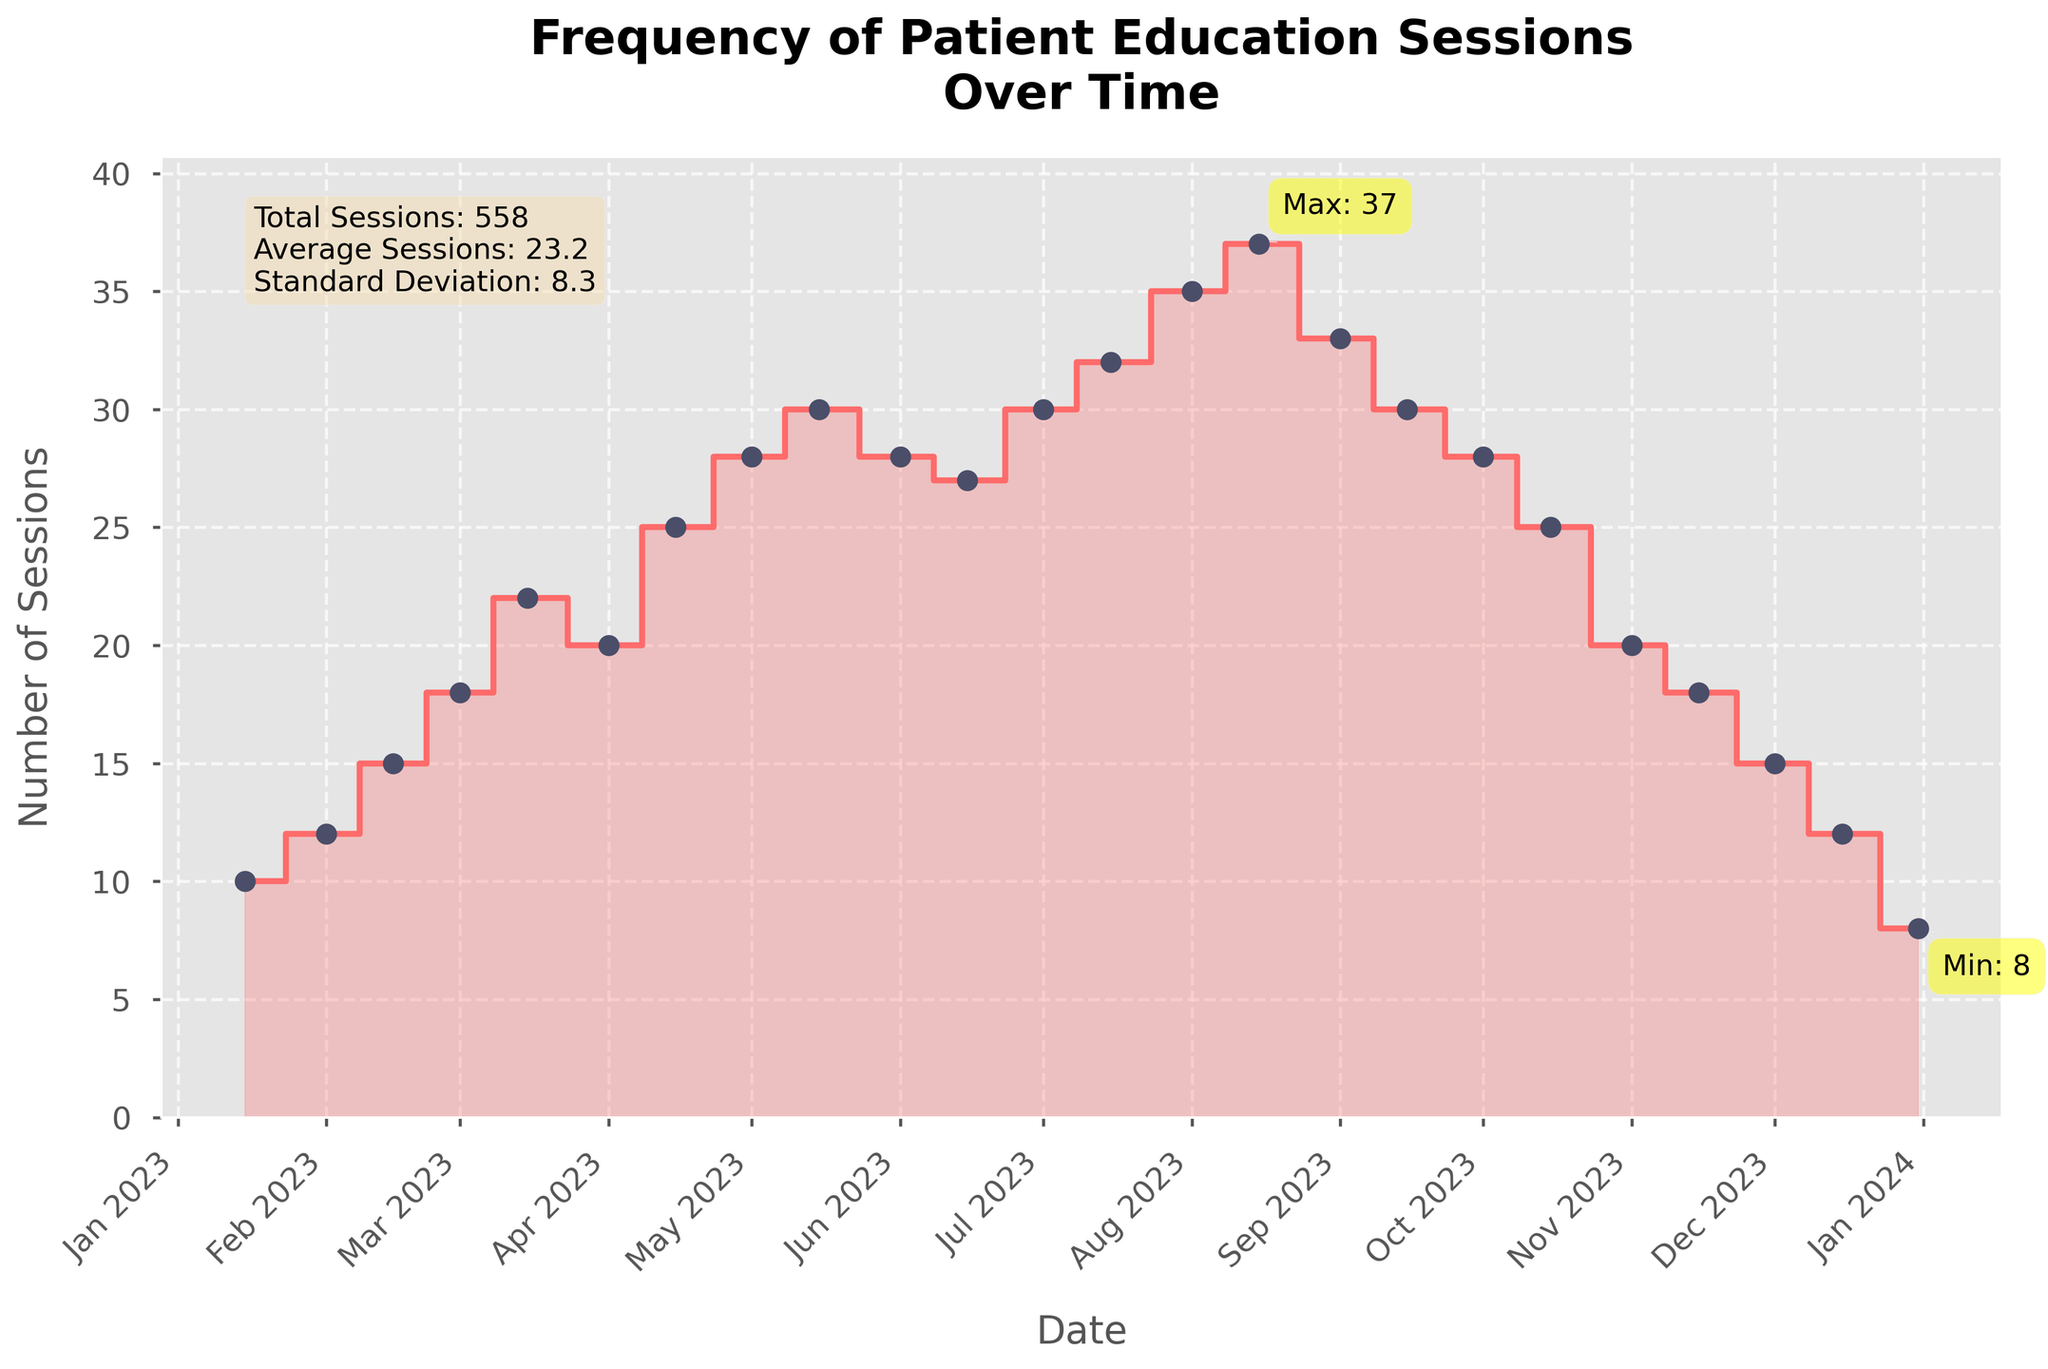How many patient education sessions were conducted in total over the year? The total number of sessions is given by the sum of all the data points representing the frequency of sessions. Summing them up gives us the total number of sessions conducted throughout the year.
Answer: 483 When was the highest number of patient education sessions conducted, and how many were there? To find the highest number of sessions conducted, look for the peak in the stair plot. The annotation indicates the maximum value. According to the figure, the highest number of sessions, 37, was conducted around August 15, 2023.
Answer: August 15, 2023, 37 How many sessions were conducted in June 2023? Observing the stair plot, the number of sessions on June 1, 2023, is 28, and on June 15, 2023, it is 27.
Answer: 28 and 27 How does the frequency of sessions in December 2023 compare to that in July 2023? The stair plot shows that in July 2023, the number of sessions was 30 and increased to 32. In contrast, December 2023 started at 15 and decreased to 8 by the end of the month. Thus, the frequency in July is higher than in December.
Answer: July > December What is the trend of patient education sessions from January to March 2023? Observing the stair plot from January to March, there is an increasing trend. Sessions start at 10 in January and gradually rise to 22 by mid-March.
Answer: Increasing By how much did the frequency of sessions change from mid-April to mid-May 2023? Mid-April had 25 sessions, and mid-May had 30 sessions. Subtracting 25 from 30 gives the change.
Answer: Increase by 5 What is the average number of sessions conducted per month? The total number of sessions divided by the number of months (12) gives the average number of sessions per month. Total sessions are 483, so 483/12 = 40.25.
Answer: 40.25 What is the least number of patient education sessions conducted, and when did it occur? According to the annotation on the stair plot, the fewest sessions, 8, occurred on December 31, 2023.
Answer: December 31, 2023, 8 What month had the largest drop in sessions, and what was the difference? The largest drop is observed from mid-September (30) to mid-October (25), a difference of 5 sessions.
Answer: October, 5 